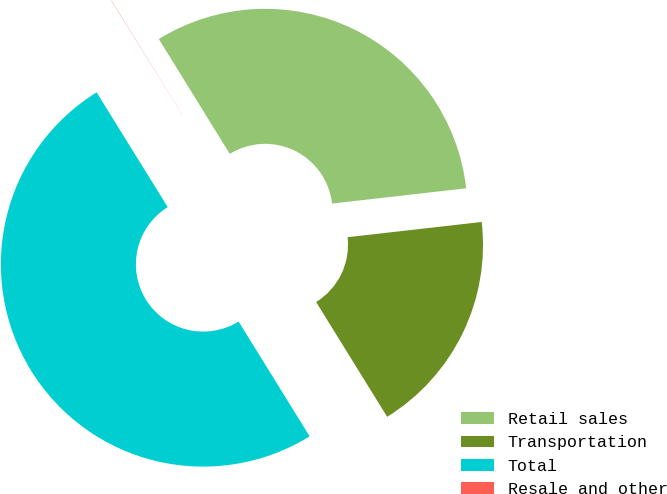<chart> <loc_0><loc_0><loc_500><loc_500><pie_chart><fcel>Retail sales<fcel>Transportation<fcel>Total<fcel>Resale and other<nl><fcel>32.01%<fcel>17.98%<fcel>49.99%<fcel>0.02%<nl></chart> 